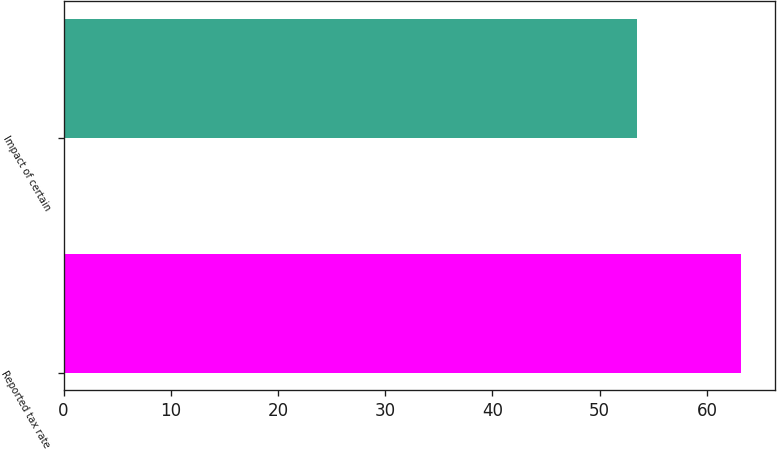Convert chart to OTSL. <chart><loc_0><loc_0><loc_500><loc_500><bar_chart><fcel>Reported tax rate<fcel>Impact of certain<nl><fcel>63.2<fcel>53.5<nl></chart> 